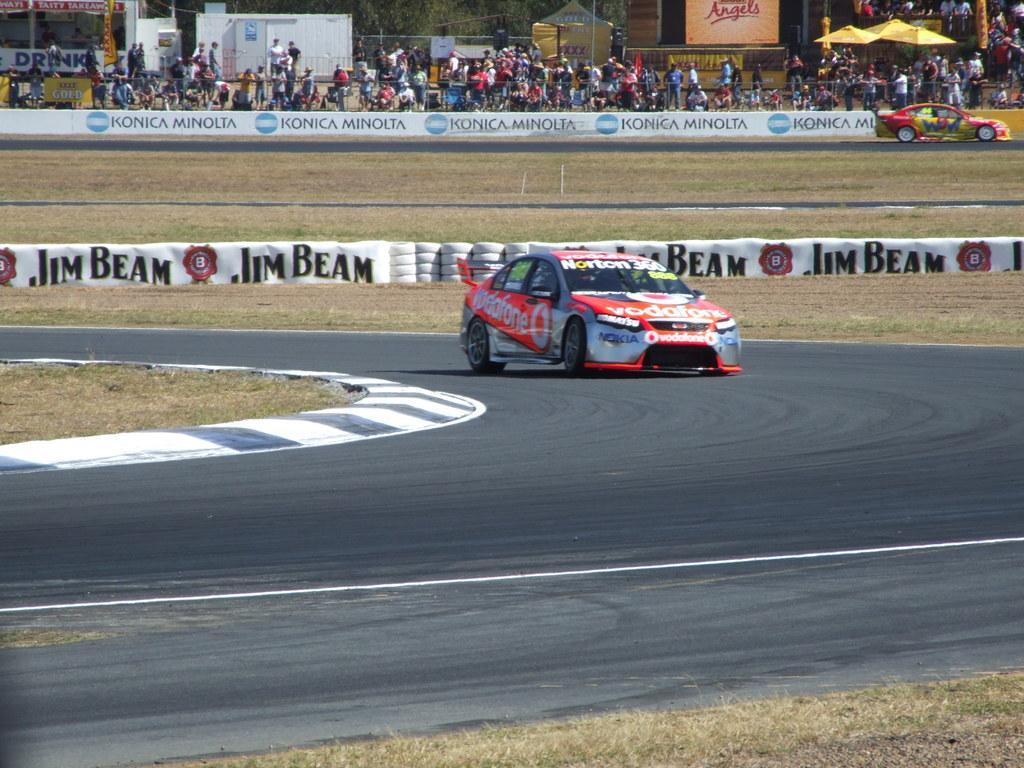In one or two sentences, can you explain what this image depicts? We can see a car on the road, grass, banners and tyres. In the background we can see hoardings, car on the road, people, tents, screen, stage, wall, glass and trees. 